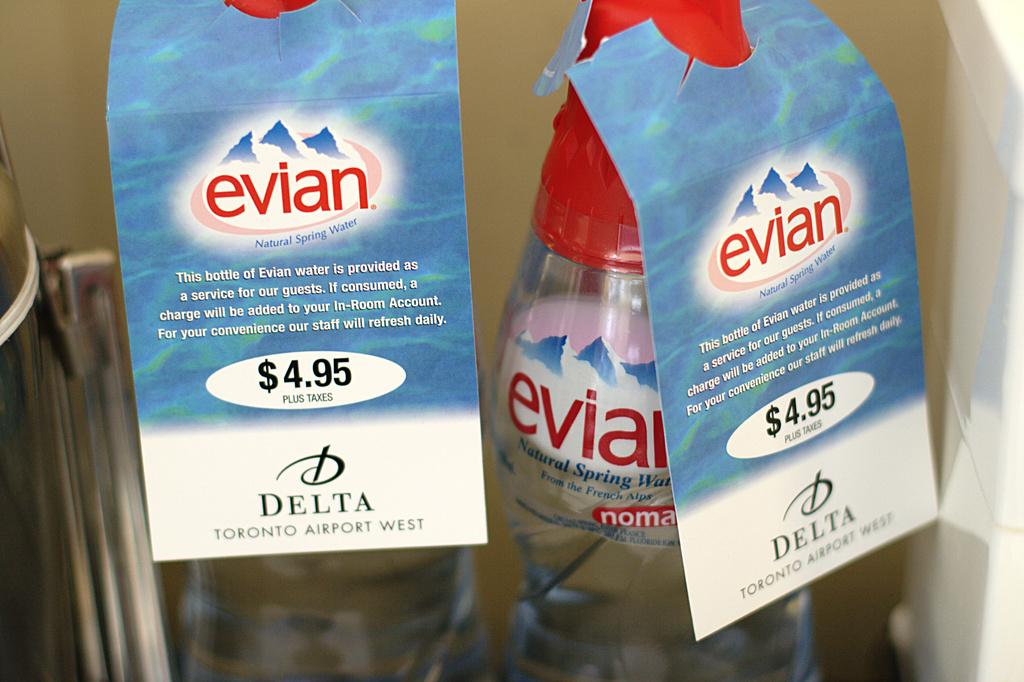<image>
Write a terse but informative summary of the picture. two bottles of Evian water for $4.95 for sale from Delta 